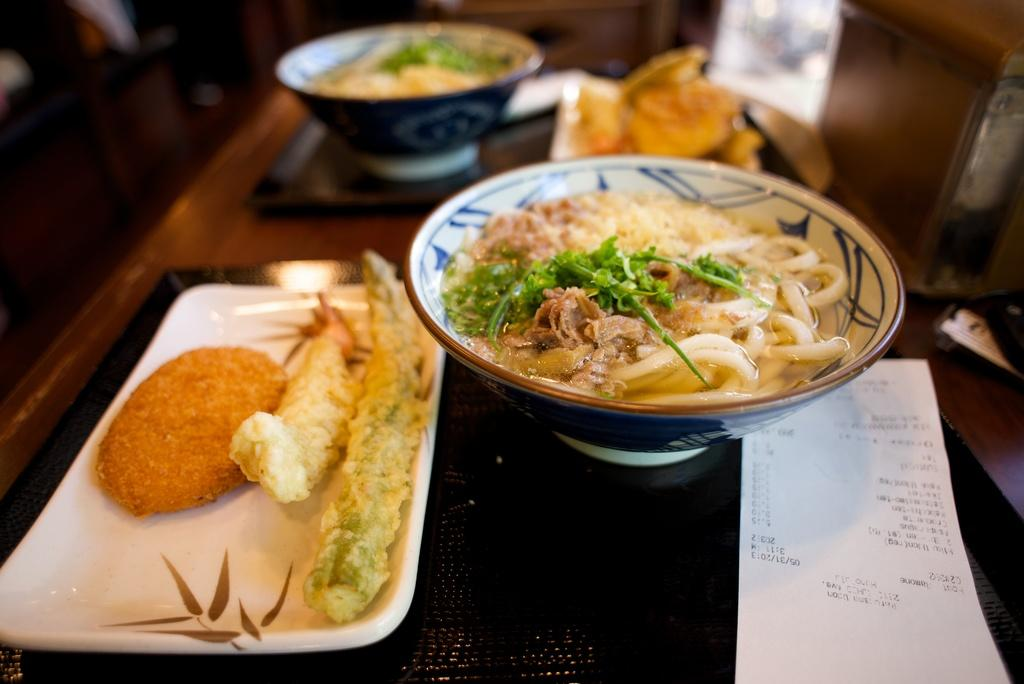How many bowls with food are visible in the image? There are two bowls with food in the image. How many plates with food are visible in the image? There are two plates with food in the image. What is the purpose of the paper with text in the image? The purpose of the paper with text is not clear from the image, but it may contain information or instructions related to the food. What can be found on the table in the image? There are objects on the table in the image, including the bowls, plates, and paper with text. What can be found on the floor in the image? There are objects on the floor in the image, but their specific nature is not clear from the provided facts. How would you describe the background of the image? The background of the image is blurred, making it difficult to discern specific details. What type of government is depicted in the image? There is no depiction of a government in the image; it features bowls, plates, and food. How many screws can be seen in the image? There are no screws present in the image. 